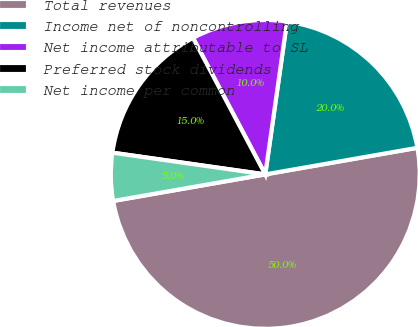Convert chart. <chart><loc_0><loc_0><loc_500><loc_500><pie_chart><fcel>Total revenues<fcel>Income net of noncontrolling<fcel>Net income attributable to SL<fcel>Preferred stock dividends<fcel>Net income per common<nl><fcel>50.0%<fcel>20.0%<fcel>10.0%<fcel>15.0%<fcel>5.0%<nl></chart> 